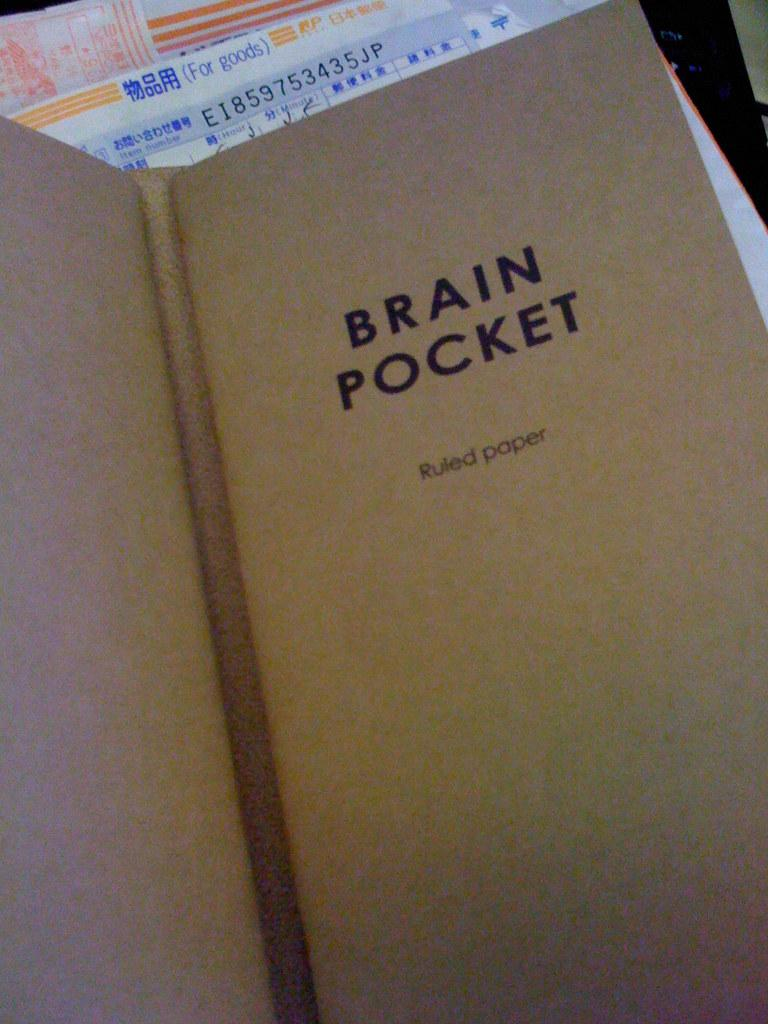<image>
Relay a brief, clear account of the picture shown. A book about Brain Pocket and ruled paper. 